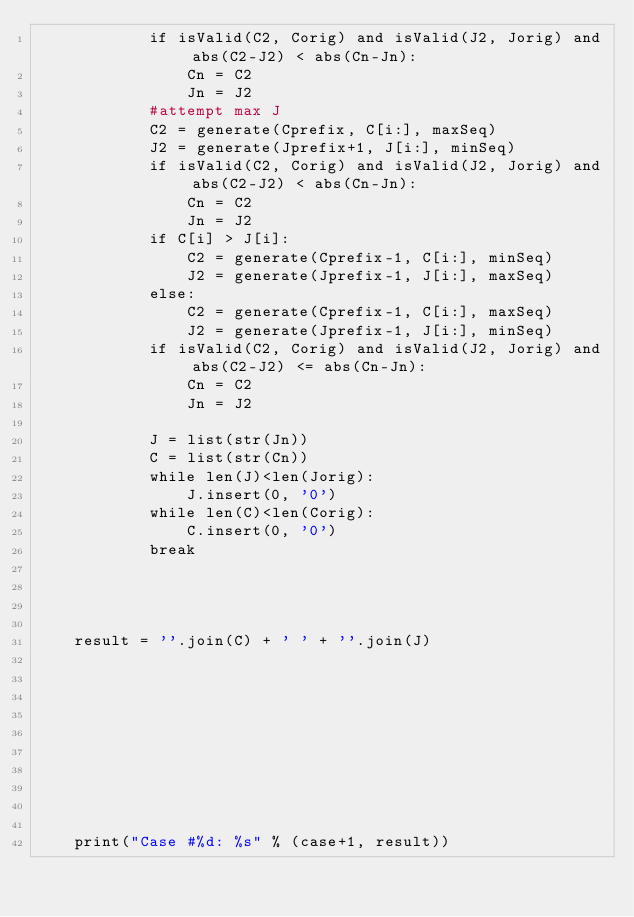Convert code to text. <code><loc_0><loc_0><loc_500><loc_500><_Python_>            if isValid(C2, Corig) and isValid(J2, Jorig) and abs(C2-J2) < abs(Cn-Jn):
                Cn = C2
                Jn = J2
            #attempt max J
            C2 = generate(Cprefix, C[i:], maxSeq)
            J2 = generate(Jprefix+1, J[i:], minSeq)
            if isValid(C2, Corig) and isValid(J2, Jorig) and abs(C2-J2) < abs(Cn-Jn):
                Cn = C2
                Jn = J2
            if C[i] > J[i]:
                C2 = generate(Cprefix-1, C[i:], minSeq)
                J2 = generate(Jprefix-1, J[i:], maxSeq)
            else:
                C2 = generate(Cprefix-1, C[i:], maxSeq)
                J2 = generate(Jprefix-1, J[i:], minSeq)
            if isValid(C2, Corig) and isValid(J2, Jorig) and abs(C2-J2) <= abs(Cn-Jn):
                Cn = C2
                Jn = J2

            J = list(str(Jn))
            C = list(str(Cn))
            while len(J)<len(Jorig):
                J.insert(0, '0')
            while len(C)<len(Corig):
                C.insert(0, '0')
            break


            

    result = ''.join(C) + ' ' + ''.join(J)










    print("Case #%d: %s" % (case+1, result))
</code> 